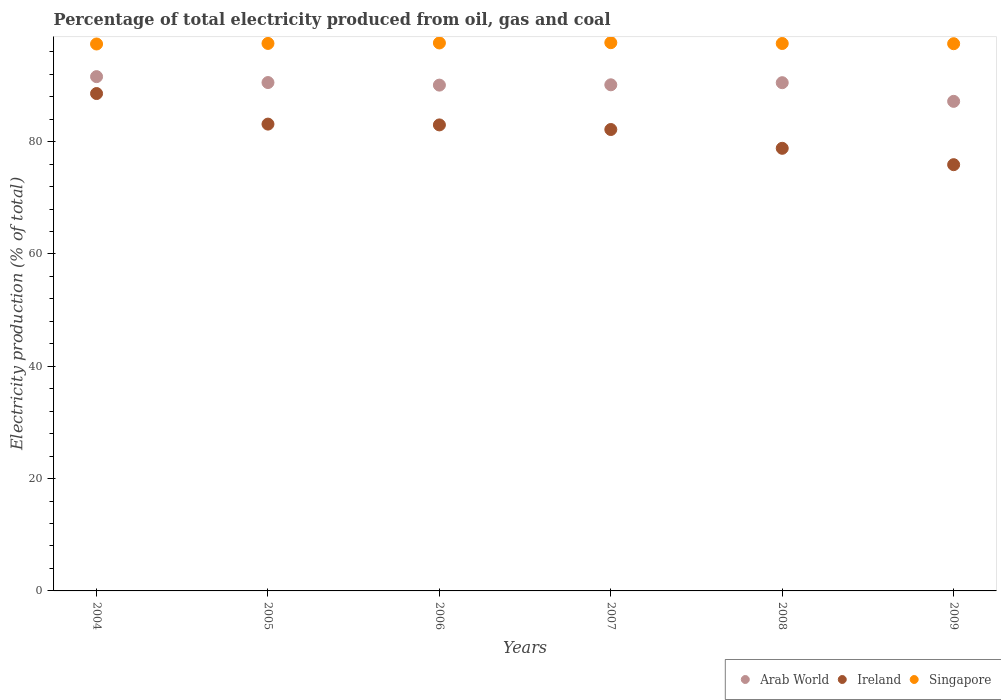What is the electricity production in in Arab World in 2006?
Provide a short and direct response. 90.07. Across all years, what is the maximum electricity production in in Ireland?
Ensure brevity in your answer.  88.57. Across all years, what is the minimum electricity production in in Arab World?
Provide a short and direct response. 87.18. What is the total electricity production in in Singapore in the graph?
Keep it short and to the point. 585.04. What is the difference between the electricity production in in Singapore in 2006 and that in 2008?
Your answer should be very brief. 0.1. What is the difference between the electricity production in in Ireland in 2006 and the electricity production in in Singapore in 2008?
Your answer should be very brief. -14.5. What is the average electricity production in in Singapore per year?
Your answer should be very brief. 97.51. In the year 2009, what is the difference between the electricity production in in Ireland and electricity production in in Singapore?
Your response must be concise. -21.54. In how many years, is the electricity production in in Singapore greater than 44 %?
Ensure brevity in your answer.  6. What is the ratio of the electricity production in in Ireland in 2006 to that in 2008?
Provide a short and direct response. 1.05. Is the electricity production in in Arab World in 2007 less than that in 2008?
Offer a terse response. Yes. What is the difference between the highest and the second highest electricity production in in Arab World?
Your response must be concise. 1.05. What is the difference between the highest and the lowest electricity production in in Singapore?
Your answer should be very brief. 0.23. Is the sum of the electricity production in in Arab World in 2008 and 2009 greater than the maximum electricity production in in Ireland across all years?
Keep it short and to the point. Yes. Is it the case that in every year, the sum of the electricity production in in Ireland and electricity production in in Arab World  is greater than the electricity production in in Singapore?
Provide a short and direct response. Yes. Does the electricity production in in Arab World monotonically increase over the years?
Offer a very short reply. No. Is the electricity production in in Singapore strictly greater than the electricity production in in Arab World over the years?
Ensure brevity in your answer.  Yes. Is the electricity production in in Arab World strictly less than the electricity production in in Ireland over the years?
Provide a succinct answer. No. What is the difference between two consecutive major ticks on the Y-axis?
Your answer should be compact. 20. Does the graph contain any zero values?
Keep it short and to the point. No. Does the graph contain grids?
Offer a terse response. No. Where does the legend appear in the graph?
Your answer should be compact. Bottom right. How many legend labels are there?
Ensure brevity in your answer.  3. What is the title of the graph?
Offer a very short reply. Percentage of total electricity produced from oil, gas and coal. Does "Denmark" appear as one of the legend labels in the graph?
Offer a very short reply. No. What is the label or title of the Y-axis?
Ensure brevity in your answer.  Electricity production (% of total). What is the Electricity production (% of total) of Arab World in 2004?
Offer a very short reply. 91.59. What is the Electricity production (% of total) in Ireland in 2004?
Provide a short and direct response. 88.57. What is the Electricity production (% of total) in Singapore in 2004?
Give a very brief answer. 97.4. What is the Electricity production (% of total) in Arab World in 2005?
Give a very brief answer. 90.53. What is the Electricity production (% of total) of Ireland in 2005?
Provide a short and direct response. 83.13. What is the Electricity production (% of total) in Singapore in 2005?
Offer a very short reply. 97.5. What is the Electricity production (% of total) in Arab World in 2006?
Offer a very short reply. 90.07. What is the Electricity production (% of total) of Ireland in 2006?
Make the answer very short. 82.99. What is the Electricity production (% of total) in Singapore in 2006?
Offer a very short reply. 97.58. What is the Electricity production (% of total) in Arab World in 2007?
Your answer should be compact. 90.13. What is the Electricity production (% of total) of Ireland in 2007?
Keep it short and to the point. 82.17. What is the Electricity production (% of total) of Singapore in 2007?
Offer a terse response. 97.63. What is the Electricity production (% of total) of Arab World in 2008?
Provide a short and direct response. 90.51. What is the Electricity production (% of total) in Ireland in 2008?
Ensure brevity in your answer.  78.82. What is the Electricity production (% of total) in Singapore in 2008?
Provide a succinct answer. 97.49. What is the Electricity production (% of total) in Arab World in 2009?
Keep it short and to the point. 87.18. What is the Electricity production (% of total) in Ireland in 2009?
Provide a succinct answer. 75.91. What is the Electricity production (% of total) in Singapore in 2009?
Make the answer very short. 97.45. Across all years, what is the maximum Electricity production (% of total) of Arab World?
Provide a succinct answer. 91.59. Across all years, what is the maximum Electricity production (% of total) in Ireland?
Offer a terse response. 88.57. Across all years, what is the maximum Electricity production (% of total) in Singapore?
Offer a very short reply. 97.63. Across all years, what is the minimum Electricity production (% of total) of Arab World?
Give a very brief answer. 87.18. Across all years, what is the minimum Electricity production (% of total) in Ireland?
Keep it short and to the point. 75.91. Across all years, what is the minimum Electricity production (% of total) of Singapore?
Offer a very short reply. 97.4. What is the total Electricity production (% of total) in Arab World in the graph?
Your answer should be compact. 540.01. What is the total Electricity production (% of total) of Ireland in the graph?
Your answer should be compact. 491.59. What is the total Electricity production (% of total) in Singapore in the graph?
Provide a short and direct response. 585.04. What is the difference between the Electricity production (% of total) of Arab World in 2004 and that in 2005?
Provide a succinct answer. 1.05. What is the difference between the Electricity production (% of total) of Ireland in 2004 and that in 2005?
Offer a very short reply. 5.44. What is the difference between the Electricity production (% of total) in Singapore in 2004 and that in 2005?
Your answer should be very brief. -0.1. What is the difference between the Electricity production (% of total) of Arab World in 2004 and that in 2006?
Your response must be concise. 1.51. What is the difference between the Electricity production (% of total) in Ireland in 2004 and that in 2006?
Your answer should be very brief. 5.59. What is the difference between the Electricity production (% of total) in Singapore in 2004 and that in 2006?
Offer a terse response. -0.18. What is the difference between the Electricity production (% of total) of Arab World in 2004 and that in 2007?
Provide a short and direct response. 1.46. What is the difference between the Electricity production (% of total) of Ireland in 2004 and that in 2007?
Offer a terse response. 6.41. What is the difference between the Electricity production (% of total) in Singapore in 2004 and that in 2007?
Your answer should be very brief. -0.23. What is the difference between the Electricity production (% of total) of Arab World in 2004 and that in 2008?
Your answer should be compact. 1.08. What is the difference between the Electricity production (% of total) in Ireland in 2004 and that in 2008?
Make the answer very short. 9.75. What is the difference between the Electricity production (% of total) in Singapore in 2004 and that in 2008?
Ensure brevity in your answer.  -0.09. What is the difference between the Electricity production (% of total) in Arab World in 2004 and that in 2009?
Your answer should be very brief. 4.4. What is the difference between the Electricity production (% of total) of Ireland in 2004 and that in 2009?
Your response must be concise. 12.67. What is the difference between the Electricity production (% of total) of Singapore in 2004 and that in 2009?
Ensure brevity in your answer.  -0.05. What is the difference between the Electricity production (% of total) of Arab World in 2005 and that in 2006?
Provide a short and direct response. 0.46. What is the difference between the Electricity production (% of total) in Ireland in 2005 and that in 2006?
Provide a short and direct response. 0.14. What is the difference between the Electricity production (% of total) of Singapore in 2005 and that in 2006?
Offer a very short reply. -0.08. What is the difference between the Electricity production (% of total) in Arab World in 2005 and that in 2007?
Make the answer very short. 0.4. What is the difference between the Electricity production (% of total) of Ireland in 2005 and that in 2007?
Your response must be concise. 0.96. What is the difference between the Electricity production (% of total) in Singapore in 2005 and that in 2007?
Make the answer very short. -0.13. What is the difference between the Electricity production (% of total) of Arab World in 2005 and that in 2008?
Offer a terse response. 0.03. What is the difference between the Electricity production (% of total) of Ireland in 2005 and that in 2008?
Provide a short and direct response. 4.31. What is the difference between the Electricity production (% of total) in Singapore in 2005 and that in 2008?
Offer a terse response. 0.01. What is the difference between the Electricity production (% of total) in Arab World in 2005 and that in 2009?
Your response must be concise. 3.35. What is the difference between the Electricity production (% of total) of Ireland in 2005 and that in 2009?
Your answer should be very brief. 7.22. What is the difference between the Electricity production (% of total) of Singapore in 2005 and that in 2009?
Give a very brief answer. 0.05. What is the difference between the Electricity production (% of total) in Arab World in 2006 and that in 2007?
Provide a succinct answer. -0.06. What is the difference between the Electricity production (% of total) of Ireland in 2006 and that in 2007?
Your answer should be very brief. 0.82. What is the difference between the Electricity production (% of total) of Singapore in 2006 and that in 2007?
Offer a terse response. -0.05. What is the difference between the Electricity production (% of total) of Arab World in 2006 and that in 2008?
Your answer should be very brief. -0.43. What is the difference between the Electricity production (% of total) of Ireland in 2006 and that in 2008?
Provide a succinct answer. 4.17. What is the difference between the Electricity production (% of total) of Singapore in 2006 and that in 2008?
Provide a short and direct response. 0.1. What is the difference between the Electricity production (% of total) in Arab World in 2006 and that in 2009?
Provide a succinct answer. 2.89. What is the difference between the Electricity production (% of total) of Ireland in 2006 and that in 2009?
Your answer should be compact. 7.08. What is the difference between the Electricity production (% of total) in Singapore in 2006 and that in 2009?
Offer a very short reply. 0.13. What is the difference between the Electricity production (% of total) in Arab World in 2007 and that in 2008?
Offer a very short reply. -0.38. What is the difference between the Electricity production (% of total) in Ireland in 2007 and that in 2008?
Keep it short and to the point. 3.35. What is the difference between the Electricity production (% of total) of Singapore in 2007 and that in 2008?
Offer a very short reply. 0.15. What is the difference between the Electricity production (% of total) of Arab World in 2007 and that in 2009?
Your response must be concise. 2.95. What is the difference between the Electricity production (% of total) of Ireland in 2007 and that in 2009?
Your response must be concise. 6.26. What is the difference between the Electricity production (% of total) of Singapore in 2007 and that in 2009?
Your answer should be very brief. 0.18. What is the difference between the Electricity production (% of total) in Arab World in 2008 and that in 2009?
Provide a succinct answer. 3.32. What is the difference between the Electricity production (% of total) of Ireland in 2008 and that in 2009?
Ensure brevity in your answer.  2.92. What is the difference between the Electricity production (% of total) in Singapore in 2008 and that in 2009?
Offer a very short reply. 0.04. What is the difference between the Electricity production (% of total) in Arab World in 2004 and the Electricity production (% of total) in Ireland in 2005?
Make the answer very short. 8.45. What is the difference between the Electricity production (% of total) of Arab World in 2004 and the Electricity production (% of total) of Singapore in 2005?
Your response must be concise. -5.91. What is the difference between the Electricity production (% of total) of Ireland in 2004 and the Electricity production (% of total) of Singapore in 2005?
Ensure brevity in your answer.  -8.92. What is the difference between the Electricity production (% of total) of Arab World in 2004 and the Electricity production (% of total) of Ireland in 2006?
Offer a terse response. 8.6. What is the difference between the Electricity production (% of total) in Arab World in 2004 and the Electricity production (% of total) in Singapore in 2006?
Your response must be concise. -6. What is the difference between the Electricity production (% of total) of Ireland in 2004 and the Electricity production (% of total) of Singapore in 2006?
Offer a terse response. -9.01. What is the difference between the Electricity production (% of total) of Arab World in 2004 and the Electricity production (% of total) of Ireland in 2007?
Your answer should be very brief. 9.42. What is the difference between the Electricity production (% of total) in Arab World in 2004 and the Electricity production (% of total) in Singapore in 2007?
Your response must be concise. -6.05. What is the difference between the Electricity production (% of total) of Ireland in 2004 and the Electricity production (% of total) of Singapore in 2007?
Offer a terse response. -9.06. What is the difference between the Electricity production (% of total) in Arab World in 2004 and the Electricity production (% of total) in Ireland in 2008?
Provide a succinct answer. 12.76. What is the difference between the Electricity production (% of total) in Arab World in 2004 and the Electricity production (% of total) in Singapore in 2008?
Provide a succinct answer. -5.9. What is the difference between the Electricity production (% of total) in Ireland in 2004 and the Electricity production (% of total) in Singapore in 2008?
Keep it short and to the point. -8.91. What is the difference between the Electricity production (% of total) of Arab World in 2004 and the Electricity production (% of total) of Ireland in 2009?
Provide a succinct answer. 15.68. What is the difference between the Electricity production (% of total) in Arab World in 2004 and the Electricity production (% of total) in Singapore in 2009?
Provide a short and direct response. -5.86. What is the difference between the Electricity production (% of total) in Ireland in 2004 and the Electricity production (% of total) in Singapore in 2009?
Your answer should be compact. -8.87. What is the difference between the Electricity production (% of total) of Arab World in 2005 and the Electricity production (% of total) of Ireland in 2006?
Keep it short and to the point. 7.54. What is the difference between the Electricity production (% of total) of Arab World in 2005 and the Electricity production (% of total) of Singapore in 2006?
Offer a terse response. -7.05. What is the difference between the Electricity production (% of total) in Ireland in 2005 and the Electricity production (% of total) in Singapore in 2006?
Keep it short and to the point. -14.45. What is the difference between the Electricity production (% of total) in Arab World in 2005 and the Electricity production (% of total) in Ireland in 2007?
Your answer should be very brief. 8.36. What is the difference between the Electricity production (% of total) of Arab World in 2005 and the Electricity production (% of total) of Singapore in 2007?
Your answer should be compact. -7.1. What is the difference between the Electricity production (% of total) of Ireland in 2005 and the Electricity production (% of total) of Singapore in 2007?
Your response must be concise. -14.5. What is the difference between the Electricity production (% of total) of Arab World in 2005 and the Electricity production (% of total) of Ireland in 2008?
Provide a succinct answer. 11.71. What is the difference between the Electricity production (% of total) in Arab World in 2005 and the Electricity production (% of total) in Singapore in 2008?
Give a very brief answer. -6.95. What is the difference between the Electricity production (% of total) of Ireland in 2005 and the Electricity production (% of total) of Singapore in 2008?
Provide a succinct answer. -14.36. What is the difference between the Electricity production (% of total) in Arab World in 2005 and the Electricity production (% of total) in Ireland in 2009?
Offer a terse response. 14.62. What is the difference between the Electricity production (% of total) in Arab World in 2005 and the Electricity production (% of total) in Singapore in 2009?
Provide a succinct answer. -6.92. What is the difference between the Electricity production (% of total) of Ireland in 2005 and the Electricity production (% of total) of Singapore in 2009?
Ensure brevity in your answer.  -14.32. What is the difference between the Electricity production (% of total) in Arab World in 2006 and the Electricity production (% of total) in Ireland in 2007?
Your response must be concise. 7.91. What is the difference between the Electricity production (% of total) of Arab World in 2006 and the Electricity production (% of total) of Singapore in 2007?
Provide a short and direct response. -7.56. What is the difference between the Electricity production (% of total) in Ireland in 2006 and the Electricity production (% of total) in Singapore in 2007?
Provide a short and direct response. -14.64. What is the difference between the Electricity production (% of total) of Arab World in 2006 and the Electricity production (% of total) of Ireland in 2008?
Give a very brief answer. 11.25. What is the difference between the Electricity production (% of total) of Arab World in 2006 and the Electricity production (% of total) of Singapore in 2008?
Keep it short and to the point. -7.41. What is the difference between the Electricity production (% of total) of Ireland in 2006 and the Electricity production (% of total) of Singapore in 2008?
Your answer should be compact. -14.5. What is the difference between the Electricity production (% of total) in Arab World in 2006 and the Electricity production (% of total) in Ireland in 2009?
Offer a very short reply. 14.17. What is the difference between the Electricity production (% of total) in Arab World in 2006 and the Electricity production (% of total) in Singapore in 2009?
Provide a succinct answer. -7.37. What is the difference between the Electricity production (% of total) of Ireland in 2006 and the Electricity production (% of total) of Singapore in 2009?
Offer a very short reply. -14.46. What is the difference between the Electricity production (% of total) in Arab World in 2007 and the Electricity production (% of total) in Ireland in 2008?
Keep it short and to the point. 11.31. What is the difference between the Electricity production (% of total) of Arab World in 2007 and the Electricity production (% of total) of Singapore in 2008?
Offer a terse response. -7.36. What is the difference between the Electricity production (% of total) in Ireland in 2007 and the Electricity production (% of total) in Singapore in 2008?
Give a very brief answer. -15.32. What is the difference between the Electricity production (% of total) of Arab World in 2007 and the Electricity production (% of total) of Ireland in 2009?
Provide a succinct answer. 14.22. What is the difference between the Electricity production (% of total) of Arab World in 2007 and the Electricity production (% of total) of Singapore in 2009?
Ensure brevity in your answer.  -7.32. What is the difference between the Electricity production (% of total) of Ireland in 2007 and the Electricity production (% of total) of Singapore in 2009?
Your response must be concise. -15.28. What is the difference between the Electricity production (% of total) of Arab World in 2008 and the Electricity production (% of total) of Ireland in 2009?
Your answer should be very brief. 14.6. What is the difference between the Electricity production (% of total) in Arab World in 2008 and the Electricity production (% of total) in Singapore in 2009?
Make the answer very short. -6.94. What is the difference between the Electricity production (% of total) in Ireland in 2008 and the Electricity production (% of total) in Singapore in 2009?
Provide a succinct answer. -18.63. What is the average Electricity production (% of total) in Arab World per year?
Ensure brevity in your answer.  90. What is the average Electricity production (% of total) in Ireland per year?
Provide a short and direct response. 81.93. What is the average Electricity production (% of total) of Singapore per year?
Keep it short and to the point. 97.51. In the year 2004, what is the difference between the Electricity production (% of total) in Arab World and Electricity production (% of total) in Ireland?
Provide a short and direct response. 3.01. In the year 2004, what is the difference between the Electricity production (% of total) in Arab World and Electricity production (% of total) in Singapore?
Your response must be concise. -5.81. In the year 2004, what is the difference between the Electricity production (% of total) of Ireland and Electricity production (% of total) of Singapore?
Your answer should be very brief. -8.82. In the year 2005, what is the difference between the Electricity production (% of total) of Arab World and Electricity production (% of total) of Ireland?
Your response must be concise. 7.4. In the year 2005, what is the difference between the Electricity production (% of total) of Arab World and Electricity production (% of total) of Singapore?
Keep it short and to the point. -6.97. In the year 2005, what is the difference between the Electricity production (% of total) in Ireland and Electricity production (% of total) in Singapore?
Your answer should be very brief. -14.37. In the year 2006, what is the difference between the Electricity production (% of total) of Arab World and Electricity production (% of total) of Ireland?
Keep it short and to the point. 7.09. In the year 2006, what is the difference between the Electricity production (% of total) of Arab World and Electricity production (% of total) of Singapore?
Make the answer very short. -7.51. In the year 2006, what is the difference between the Electricity production (% of total) of Ireland and Electricity production (% of total) of Singapore?
Your answer should be very brief. -14.59. In the year 2007, what is the difference between the Electricity production (% of total) of Arab World and Electricity production (% of total) of Ireland?
Offer a very short reply. 7.96. In the year 2007, what is the difference between the Electricity production (% of total) in Arab World and Electricity production (% of total) in Singapore?
Provide a succinct answer. -7.5. In the year 2007, what is the difference between the Electricity production (% of total) in Ireland and Electricity production (% of total) in Singapore?
Offer a terse response. -15.46. In the year 2008, what is the difference between the Electricity production (% of total) of Arab World and Electricity production (% of total) of Ireland?
Your response must be concise. 11.68. In the year 2008, what is the difference between the Electricity production (% of total) of Arab World and Electricity production (% of total) of Singapore?
Your answer should be compact. -6.98. In the year 2008, what is the difference between the Electricity production (% of total) of Ireland and Electricity production (% of total) of Singapore?
Provide a succinct answer. -18.66. In the year 2009, what is the difference between the Electricity production (% of total) in Arab World and Electricity production (% of total) in Ireland?
Your answer should be compact. 11.28. In the year 2009, what is the difference between the Electricity production (% of total) of Arab World and Electricity production (% of total) of Singapore?
Keep it short and to the point. -10.26. In the year 2009, what is the difference between the Electricity production (% of total) in Ireland and Electricity production (% of total) in Singapore?
Your answer should be very brief. -21.54. What is the ratio of the Electricity production (% of total) of Arab World in 2004 to that in 2005?
Provide a short and direct response. 1.01. What is the ratio of the Electricity production (% of total) of Ireland in 2004 to that in 2005?
Your answer should be compact. 1.07. What is the ratio of the Electricity production (% of total) of Arab World in 2004 to that in 2006?
Your answer should be compact. 1.02. What is the ratio of the Electricity production (% of total) in Ireland in 2004 to that in 2006?
Your response must be concise. 1.07. What is the ratio of the Electricity production (% of total) in Arab World in 2004 to that in 2007?
Your answer should be very brief. 1.02. What is the ratio of the Electricity production (% of total) of Ireland in 2004 to that in 2007?
Provide a succinct answer. 1.08. What is the ratio of the Electricity production (% of total) of Singapore in 2004 to that in 2007?
Ensure brevity in your answer.  1. What is the ratio of the Electricity production (% of total) of Arab World in 2004 to that in 2008?
Keep it short and to the point. 1.01. What is the ratio of the Electricity production (% of total) in Ireland in 2004 to that in 2008?
Your answer should be very brief. 1.12. What is the ratio of the Electricity production (% of total) of Arab World in 2004 to that in 2009?
Make the answer very short. 1.05. What is the ratio of the Electricity production (% of total) in Ireland in 2004 to that in 2009?
Ensure brevity in your answer.  1.17. What is the ratio of the Electricity production (% of total) in Ireland in 2005 to that in 2006?
Give a very brief answer. 1. What is the ratio of the Electricity production (% of total) of Singapore in 2005 to that in 2006?
Your response must be concise. 1. What is the ratio of the Electricity production (% of total) in Arab World in 2005 to that in 2007?
Ensure brevity in your answer.  1. What is the ratio of the Electricity production (% of total) of Ireland in 2005 to that in 2007?
Your answer should be very brief. 1.01. What is the ratio of the Electricity production (% of total) of Singapore in 2005 to that in 2007?
Your response must be concise. 1. What is the ratio of the Electricity production (% of total) of Arab World in 2005 to that in 2008?
Your answer should be compact. 1. What is the ratio of the Electricity production (% of total) in Ireland in 2005 to that in 2008?
Your answer should be very brief. 1.05. What is the ratio of the Electricity production (% of total) in Singapore in 2005 to that in 2008?
Keep it short and to the point. 1. What is the ratio of the Electricity production (% of total) of Arab World in 2005 to that in 2009?
Your answer should be very brief. 1.04. What is the ratio of the Electricity production (% of total) of Ireland in 2005 to that in 2009?
Your answer should be very brief. 1.1. What is the ratio of the Electricity production (% of total) of Ireland in 2006 to that in 2007?
Provide a succinct answer. 1.01. What is the ratio of the Electricity production (% of total) in Singapore in 2006 to that in 2007?
Provide a succinct answer. 1. What is the ratio of the Electricity production (% of total) in Ireland in 2006 to that in 2008?
Provide a short and direct response. 1.05. What is the ratio of the Electricity production (% of total) of Singapore in 2006 to that in 2008?
Provide a short and direct response. 1. What is the ratio of the Electricity production (% of total) of Arab World in 2006 to that in 2009?
Provide a succinct answer. 1.03. What is the ratio of the Electricity production (% of total) in Ireland in 2006 to that in 2009?
Give a very brief answer. 1.09. What is the ratio of the Electricity production (% of total) of Singapore in 2006 to that in 2009?
Offer a very short reply. 1. What is the ratio of the Electricity production (% of total) in Arab World in 2007 to that in 2008?
Ensure brevity in your answer.  1. What is the ratio of the Electricity production (% of total) of Ireland in 2007 to that in 2008?
Provide a short and direct response. 1.04. What is the ratio of the Electricity production (% of total) of Arab World in 2007 to that in 2009?
Provide a short and direct response. 1.03. What is the ratio of the Electricity production (% of total) in Ireland in 2007 to that in 2009?
Give a very brief answer. 1.08. What is the ratio of the Electricity production (% of total) of Arab World in 2008 to that in 2009?
Your answer should be compact. 1.04. What is the ratio of the Electricity production (% of total) in Ireland in 2008 to that in 2009?
Make the answer very short. 1.04. What is the ratio of the Electricity production (% of total) of Singapore in 2008 to that in 2009?
Provide a short and direct response. 1. What is the difference between the highest and the second highest Electricity production (% of total) of Arab World?
Your answer should be very brief. 1.05. What is the difference between the highest and the second highest Electricity production (% of total) of Ireland?
Provide a succinct answer. 5.44. What is the difference between the highest and the second highest Electricity production (% of total) in Singapore?
Offer a very short reply. 0.05. What is the difference between the highest and the lowest Electricity production (% of total) of Arab World?
Keep it short and to the point. 4.4. What is the difference between the highest and the lowest Electricity production (% of total) of Ireland?
Ensure brevity in your answer.  12.67. What is the difference between the highest and the lowest Electricity production (% of total) of Singapore?
Offer a very short reply. 0.23. 